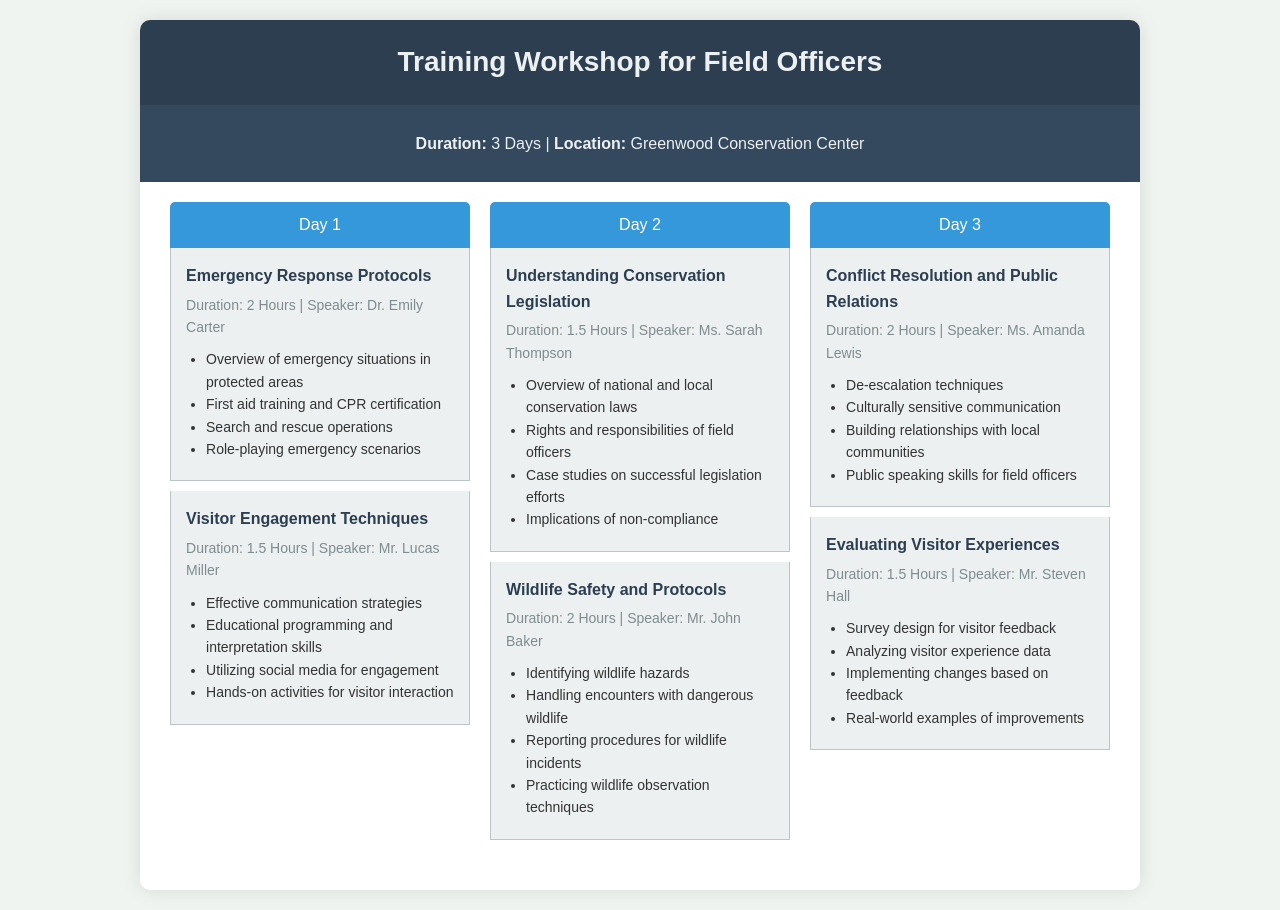What is the duration of the workshop? The duration is explicitly mentioned as "3 Days" in the workshop info section.
Answer: 3 Days Who is the speaker for the session on Emergency Response Protocols? The speaker's name is provided in the session details for Emergency Response Protocols.
Answer: Dr. Emily Carter How long is the session on Understanding Conservation Legislation? The session duration is directly stated in the session information for Understanding Conservation Legislation.
Answer: 1.5 Hours What is a key topic covered in the Visitor Engagement Techniques session? The document lists key topics covered in the session, which includes effective communication strategies.
Answer: Effective communication strategies On which day is the session about Wildlife Safety and Protocols held? The schedule presents the topics by day, indicating Wildlife Safety and Protocols is on Day 2.
Answer: Day 2 How many sessions are there on Day 3? The total number of sessions for Day 3 is mentioned under that day's schedule section.
Answer: 2 sessions What is one of the outcomes of the Evaluating Visitor Experiences session? Outcomes or goals of the session include implementing changes based on feedback.
Answer: Implementing changes based on feedback What color is used for the day header in the schedule? The color is described in the styling section of the document, specifying background color for day headers.
Answer: Blue 